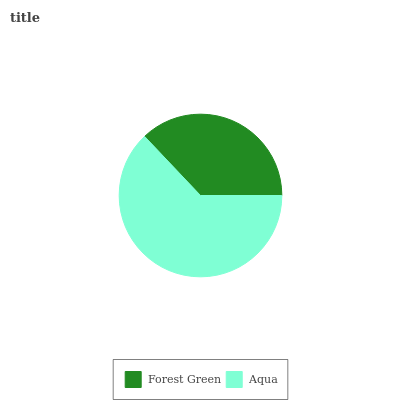Is Forest Green the minimum?
Answer yes or no. Yes. Is Aqua the maximum?
Answer yes or no. Yes. Is Aqua the minimum?
Answer yes or no. No. Is Aqua greater than Forest Green?
Answer yes or no. Yes. Is Forest Green less than Aqua?
Answer yes or no. Yes. Is Forest Green greater than Aqua?
Answer yes or no. No. Is Aqua less than Forest Green?
Answer yes or no. No. Is Aqua the high median?
Answer yes or no. Yes. Is Forest Green the low median?
Answer yes or no. Yes. Is Forest Green the high median?
Answer yes or no. No. Is Aqua the low median?
Answer yes or no. No. 